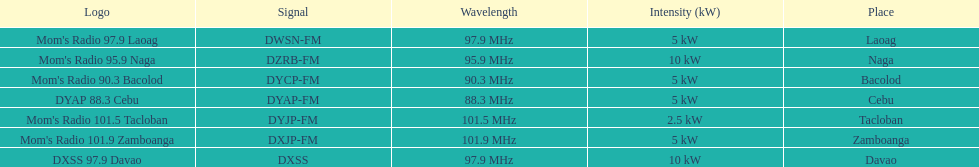What is the only radio station with a frequency below 90 mhz? DYAP 88.3 Cebu. Can you give me this table as a dict? {'header': ['Logo', 'Signal', 'Wavelength', 'Intensity (kW)', 'Place'], 'rows': [["Mom's Radio 97.9 Laoag", 'DWSN-FM', '97.9\xa0MHz', '5\xa0kW', 'Laoag'], ["Mom's Radio 95.9 Naga", 'DZRB-FM', '95.9\xa0MHz', '10\xa0kW', 'Naga'], ["Mom's Radio 90.3 Bacolod", 'DYCP-FM', '90.3\xa0MHz', '5\xa0kW', 'Bacolod'], ['DYAP 88.3 Cebu', 'DYAP-FM', '88.3\xa0MHz', '5\xa0kW', 'Cebu'], ["Mom's Radio 101.5 Tacloban", 'DYJP-FM', '101.5\xa0MHz', '2.5\xa0kW', 'Tacloban'], ["Mom's Radio 101.9 Zamboanga", 'DXJP-FM', '101.9\xa0MHz', '5\xa0kW', 'Zamboanga'], ['DXSS 97.9 Davao', 'DXSS', '97.9\xa0MHz', '10\xa0kW', 'Davao']]} 